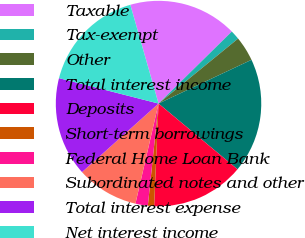<chart> <loc_0><loc_0><loc_500><loc_500><pie_chart><fcel>Taxable<fcel>Tax-exempt<fcel>Other<fcel>Total interest income<fcel>Deposits<fcel>Short-term borrowings<fcel>Federal Home Loan Bank<fcel>Subordinated notes and other<fcel>Total interest expense<fcel>Net interest income<nl><fcel>17.07%<fcel>1.46%<fcel>3.9%<fcel>18.05%<fcel>14.63%<fcel>0.98%<fcel>1.95%<fcel>9.76%<fcel>15.61%<fcel>16.59%<nl></chart> 